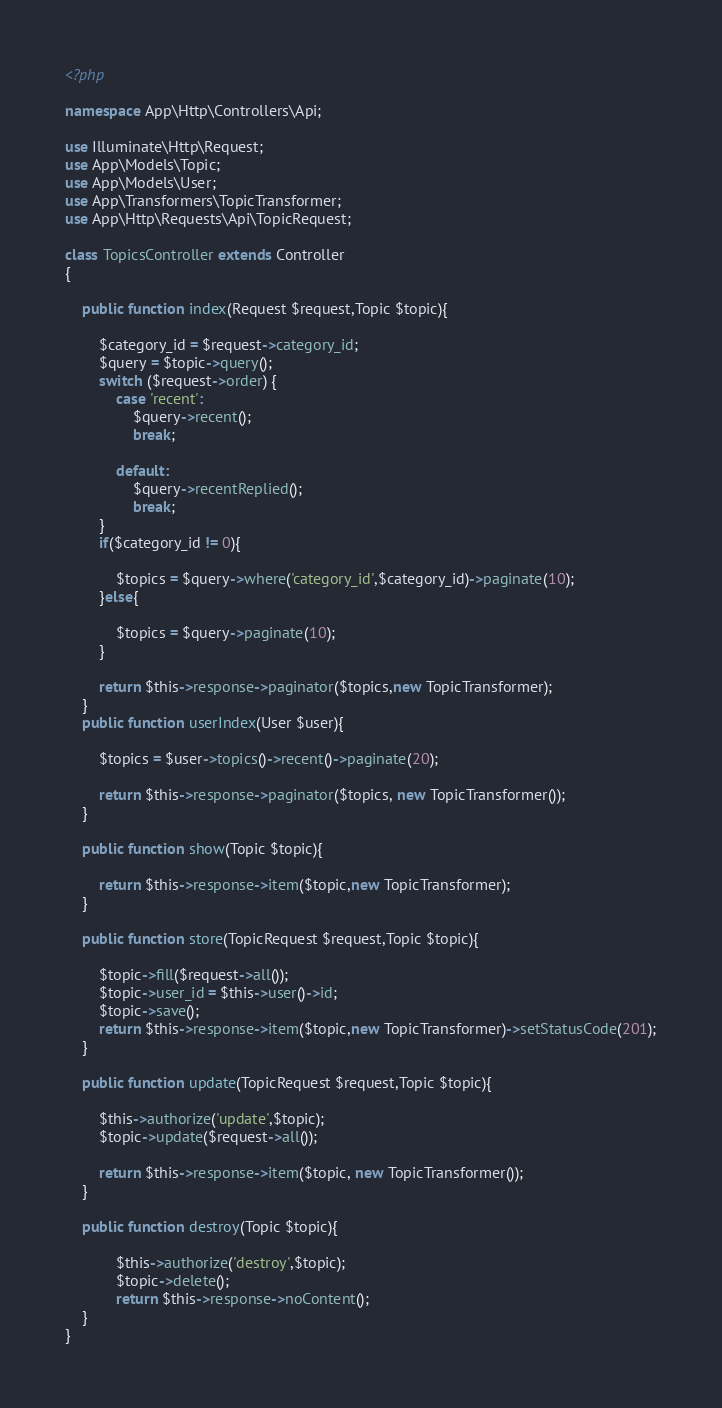<code> <loc_0><loc_0><loc_500><loc_500><_PHP_><?php

namespace App\Http\Controllers\Api;

use Illuminate\Http\Request;
use App\Models\Topic;
use App\Models\User;
use App\Transformers\TopicTransformer;
use App\Http\Requests\Api\TopicRequest;

class TopicsController extends Controller
{

	public function index(Request $request,Topic $topic){

		$category_id = $request->category_id;
		$query = $topic->query();
		switch ($request->order) {
			case 'recent':
				$query->recent();
				break;
			
			default:
				$query->recentReplied();
				break;
		}
		if($category_id != 0){

			$topics = $query->where('category_id',$category_id)->paginate(10);
		}else{

			$topics = $query->paginate(10);
		}
		
		return $this->response->paginator($topics,new TopicTransformer);
	}
 	public function userIndex(User $user){

		$topics = $user->topics()->recent()->paginate(20);

		return $this->response->paginator($topics, new TopicTransformer());
	}

	public function show(Topic $topic){

		return $this->response->item($topic,new TopicTransformer);
	}

    public function store(TopicRequest $request,Topic $topic){

    	$topic->fill($request->all());
    	$topic->user_id = $this->user()->id;
    	$topic->save();
    	return $this->response->item($topic,new TopicTransformer)->setStatusCode(201);
    }

    public function update(TopicRequest $request,Topic $topic){

    	$this->authorize('update',$topic);
    	$topic->update($request->all());

    	return $this->response->item($topic, new TopicTransformer());
    }

    public function destroy(Topic $topic){

    		$this->authorize('destroy',$topic);
    		$topic->delete();
    		return $this->response->noContent();
    }
}
</code> 